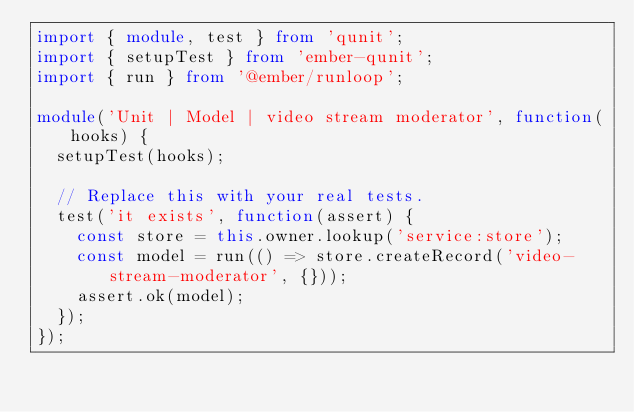<code> <loc_0><loc_0><loc_500><loc_500><_TypeScript_>import { module, test } from 'qunit';
import { setupTest } from 'ember-qunit';
import { run } from '@ember/runloop';

module('Unit | Model | video stream moderator', function(hooks) {
  setupTest(hooks);

  // Replace this with your real tests.
  test('it exists', function(assert) {
    const store = this.owner.lookup('service:store');
    const model = run(() => store.createRecord('video-stream-moderator', {}));
    assert.ok(model);
  });
});
</code> 